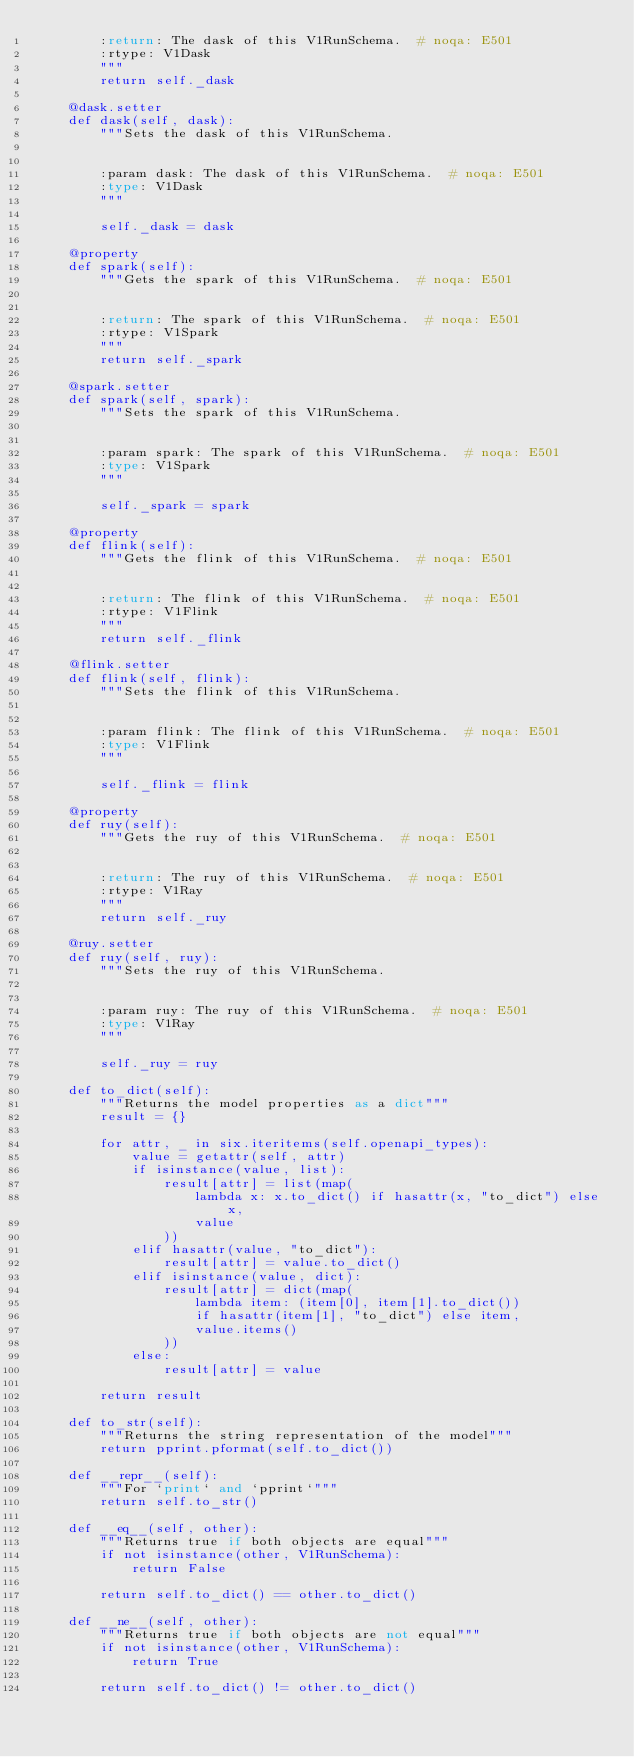Convert code to text. <code><loc_0><loc_0><loc_500><loc_500><_Python_>        :return: The dask of this V1RunSchema.  # noqa: E501
        :rtype: V1Dask
        """
        return self._dask

    @dask.setter
    def dask(self, dask):
        """Sets the dask of this V1RunSchema.


        :param dask: The dask of this V1RunSchema.  # noqa: E501
        :type: V1Dask
        """

        self._dask = dask

    @property
    def spark(self):
        """Gets the spark of this V1RunSchema.  # noqa: E501


        :return: The spark of this V1RunSchema.  # noqa: E501
        :rtype: V1Spark
        """
        return self._spark

    @spark.setter
    def spark(self, spark):
        """Sets the spark of this V1RunSchema.


        :param spark: The spark of this V1RunSchema.  # noqa: E501
        :type: V1Spark
        """

        self._spark = spark

    @property
    def flink(self):
        """Gets the flink of this V1RunSchema.  # noqa: E501


        :return: The flink of this V1RunSchema.  # noqa: E501
        :rtype: V1Flink
        """
        return self._flink

    @flink.setter
    def flink(self, flink):
        """Sets the flink of this V1RunSchema.


        :param flink: The flink of this V1RunSchema.  # noqa: E501
        :type: V1Flink
        """

        self._flink = flink

    @property
    def ruy(self):
        """Gets the ruy of this V1RunSchema.  # noqa: E501


        :return: The ruy of this V1RunSchema.  # noqa: E501
        :rtype: V1Ray
        """
        return self._ruy

    @ruy.setter
    def ruy(self, ruy):
        """Sets the ruy of this V1RunSchema.


        :param ruy: The ruy of this V1RunSchema.  # noqa: E501
        :type: V1Ray
        """

        self._ruy = ruy

    def to_dict(self):
        """Returns the model properties as a dict"""
        result = {}

        for attr, _ in six.iteritems(self.openapi_types):
            value = getattr(self, attr)
            if isinstance(value, list):
                result[attr] = list(map(
                    lambda x: x.to_dict() if hasattr(x, "to_dict") else x,
                    value
                ))
            elif hasattr(value, "to_dict"):
                result[attr] = value.to_dict()
            elif isinstance(value, dict):
                result[attr] = dict(map(
                    lambda item: (item[0], item[1].to_dict())
                    if hasattr(item[1], "to_dict") else item,
                    value.items()
                ))
            else:
                result[attr] = value

        return result

    def to_str(self):
        """Returns the string representation of the model"""
        return pprint.pformat(self.to_dict())

    def __repr__(self):
        """For `print` and `pprint`"""
        return self.to_str()

    def __eq__(self, other):
        """Returns true if both objects are equal"""
        if not isinstance(other, V1RunSchema):
            return False

        return self.to_dict() == other.to_dict()

    def __ne__(self, other):
        """Returns true if both objects are not equal"""
        if not isinstance(other, V1RunSchema):
            return True

        return self.to_dict() != other.to_dict()
</code> 